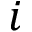<formula> <loc_0><loc_0><loc_500><loc_500>i</formula> 